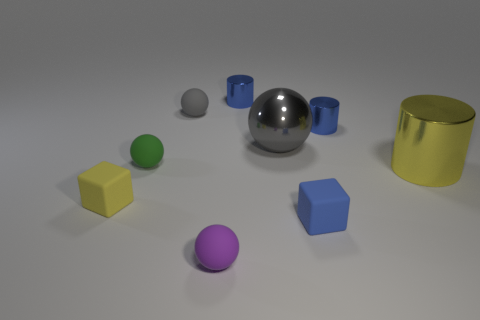Subtract 1 balls. How many balls are left? 3 Subtract all blue spheres. Subtract all purple cylinders. How many spheres are left? 4 Subtract all cubes. How many objects are left? 7 Add 5 tiny blue cylinders. How many tiny blue cylinders exist? 7 Subtract 0 blue spheres. How many objects are left? 9 Subtract all small brown rubber cylinders. Subtract all purple objects. How many objects are left? 8 Add 4 small blue cubes. How many small blue cubes are left? 5 